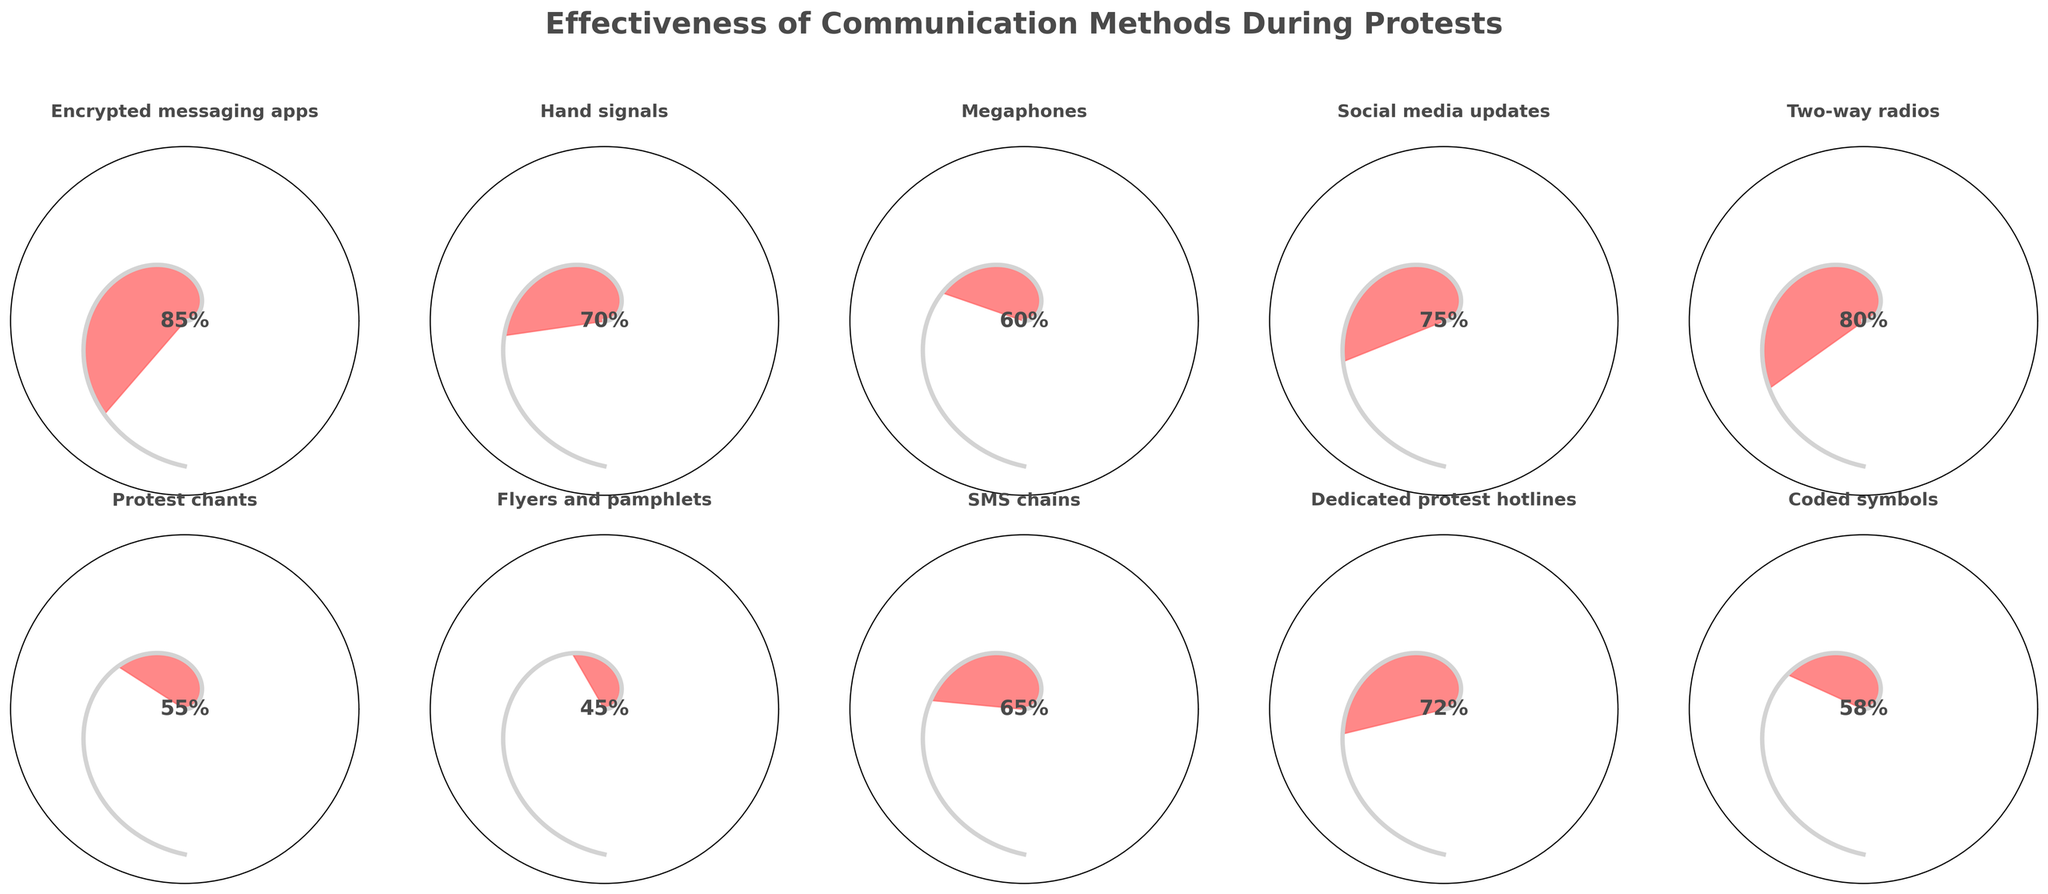What's the title of the figure? The title is usually placed at the top of the figure, often in a larger and bold font to make it easily noticeable.
Answer: Effectiveness of Communication Methods During Protests Which communication method has the highest effectiveness? By examining the individual gauges, the effectiveness value closest to 100% indicates the highest effectiveness.
Answer: Encrypted messaging apps Which communication method has the lowest effectiveness? Compare the effectiveness percentages on each gauge, looking for the smallest value.
Answer: Flyers and pamphlets What's the average effectiveness of all the communication methods? Add up all the effectiveness percentages and divide by the number of methods (10). Calculation: (85 + 70 + 60 + 75 + 80 + 55 + 45 + 65 + 72 + 58) / 10 = 66.5
Answer: 66.5% How many communication methods have an effectiveness greater than 70%? Count the methods with effectiveness values greater than 70. Encrypted messaging apps (85), Social media updates (75), Two-way radios (80), and Dedicated protest hotlines (72) meet the criterion.
Answer: 4 Which two communication methods have effectiveness values closest to each other? Find pairs of methods and compare their effectiveness values, looking for the smallest difference. Coded symbols (58) and Protest chants (55) are closest.
Answer: Protest chants and Coded symbols Is the effectiveness of two-way radios greater than social media updates? Compare the effectiveness values of two-way radios (80) and social media updates (75).
Answer: Yes Which methods have effectiveness values below 60%? Identify methods with effectiveness percentages less than 60. Flyers and pamphlets (45), Protest chants (55), and Coded symbols (58) are below 60%.
Answer: Flyers and pamphlets, Protest chants, Coded symbols 